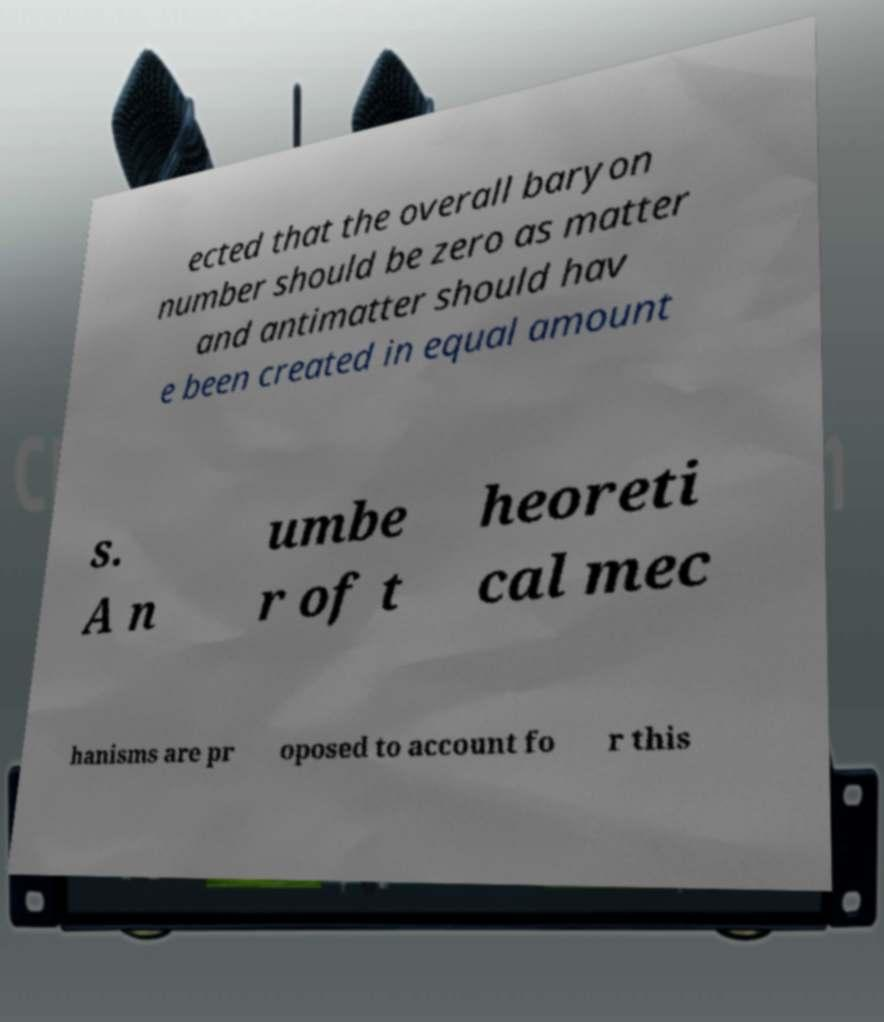For documentation purposes, I need the text within this image transcribed. Could you provide that? ected that the overall baryon number should be zero as matter and antimatter should hav e been created in equal amount s. A n umbe r of t heoreti cal mec hanisms are pr oposed to account fo r this 